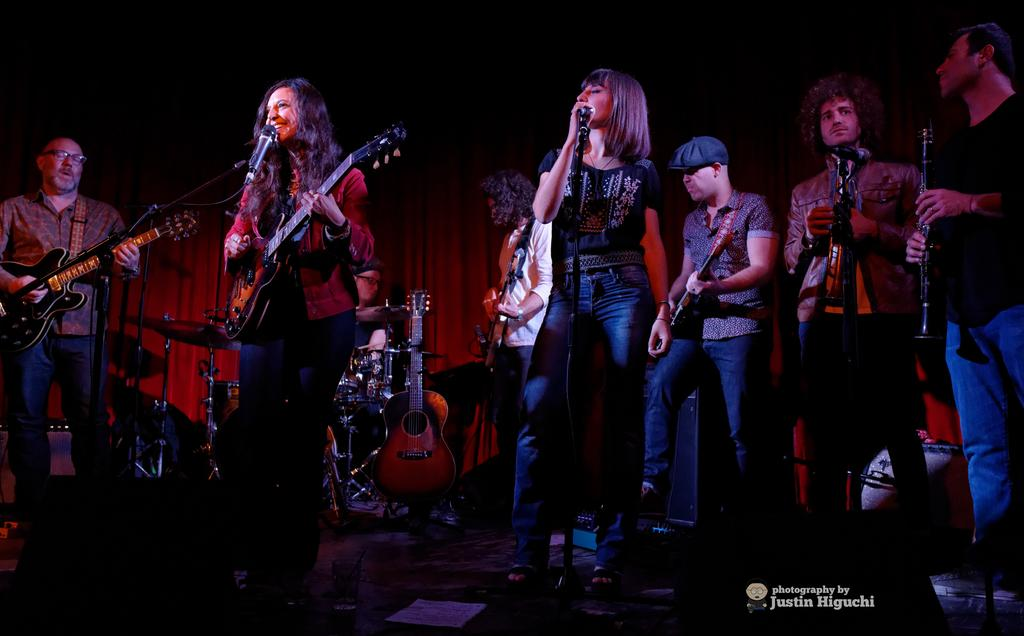What is happening in the image? There is a group of people in the image, and they are playing musical instruments. Are there any vocalists in the group? Yes, two people are singing in front of a microphone. What type of tramp can be seen in the image? There is no tramp present in the image; it features a group of people playing musical instruments and singing. What is the current temperature during the performance in the image? The provided facts do not mention the temperature, so it cannot be determined from the image. 